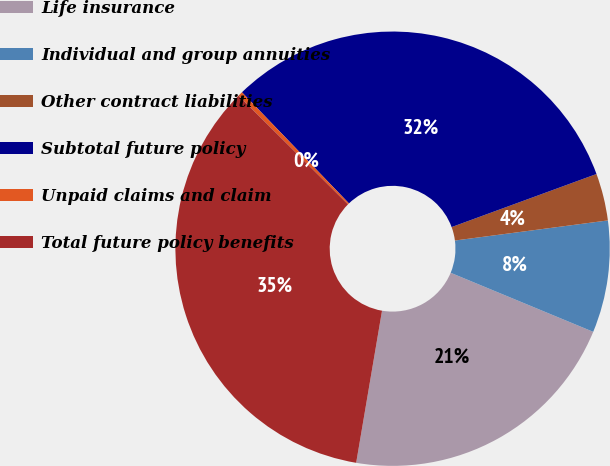Convert chart to OTSL. <chart><loc_0><loc_0><loc_500><loc_500><pie_chart><fcel>Life insurance<fcel>Individual and group annuities<fcel>Other contract liabilities<fcel>Subtotal future policy<fcel>Unpaid claims and claim<fcel>Total future policy benefits<nl><fcel>21.43%<fcel>8.33%<fcel>3.51%<fcel>31.61%<fcel>0.35%<fcel>34.77%<nl></chart> 